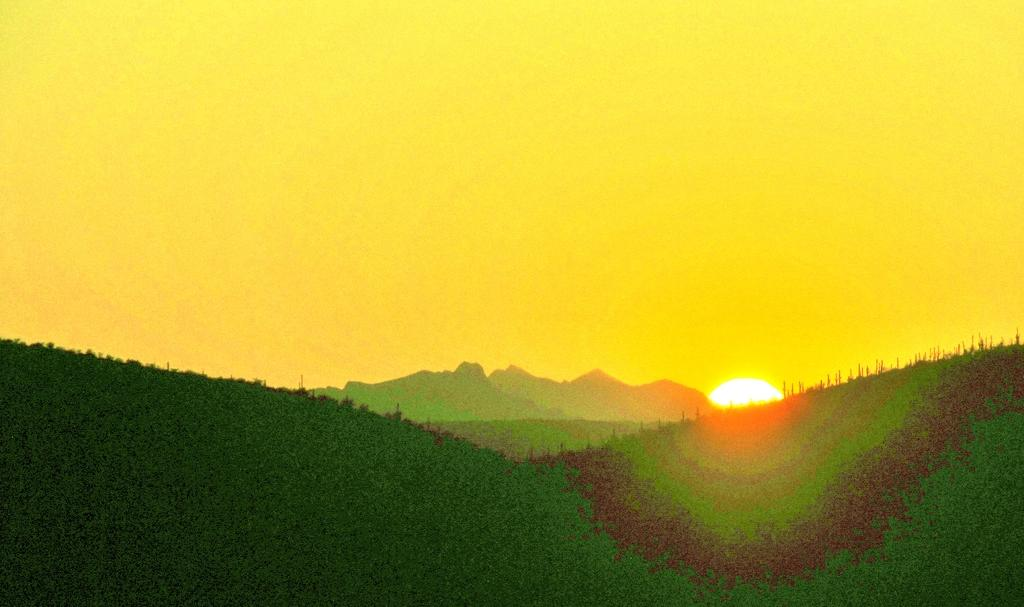What type of vegetation can be seen on the hills in the image? There is a group of trees on the hills in the image. What geographical features can be seen in the background? There are mountains visible in the background. What celestial body is visible in the image? The sun is observable in the image. What part of the natural environment is visible in the image? The sky is visible in the image. Can you see a hammer being used to crack open a nut in the image? There is no hammer or nut present in the image. How does the sun touch the trees on the hills in the image? The sun does not physically touch the trees in the image; it provides light and warmth from a distance. 